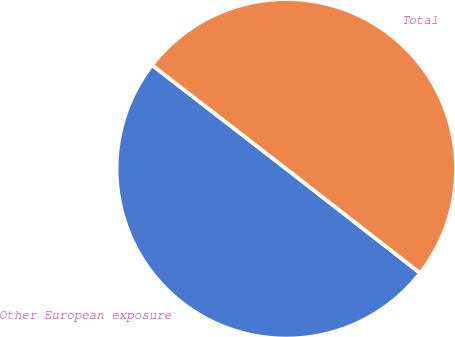<chart> <loc_0><loc_0><loc_500><loc_500><pie_chart><fcel>Other European exposure<fcel>Total<nl><fcel>49.94%<fcel>50.06%<nl></chart> 